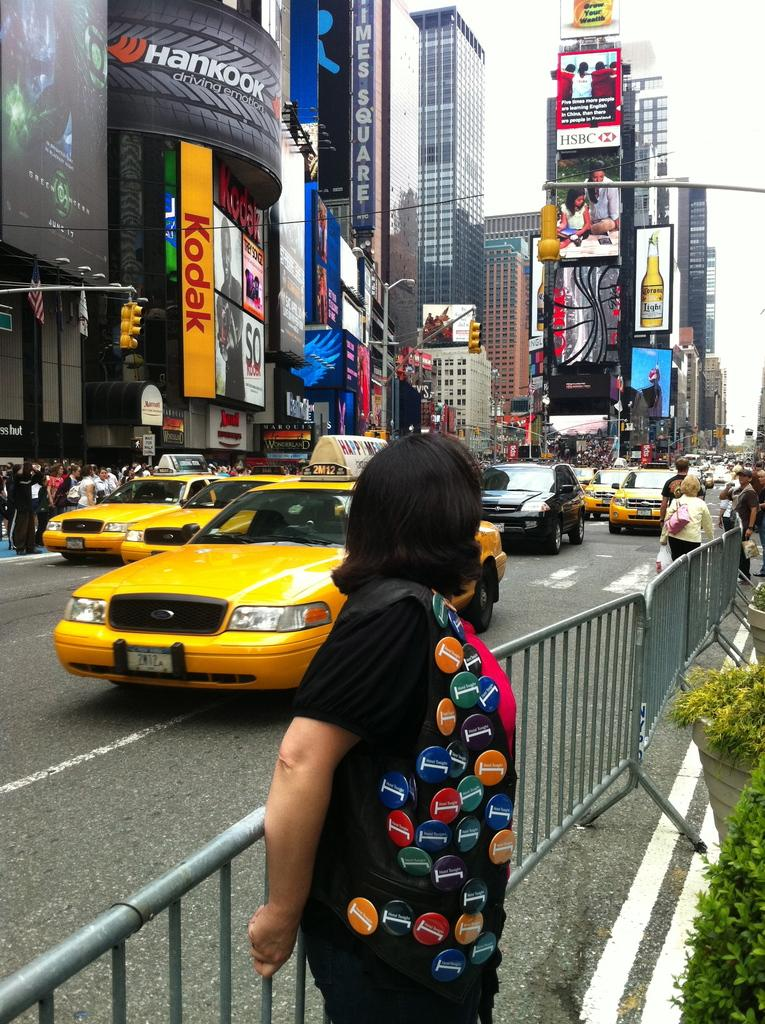<image>
Present a compact description of the photo's key features. A woman wearing many buttons stands on the side of a street near the Hankook building. 